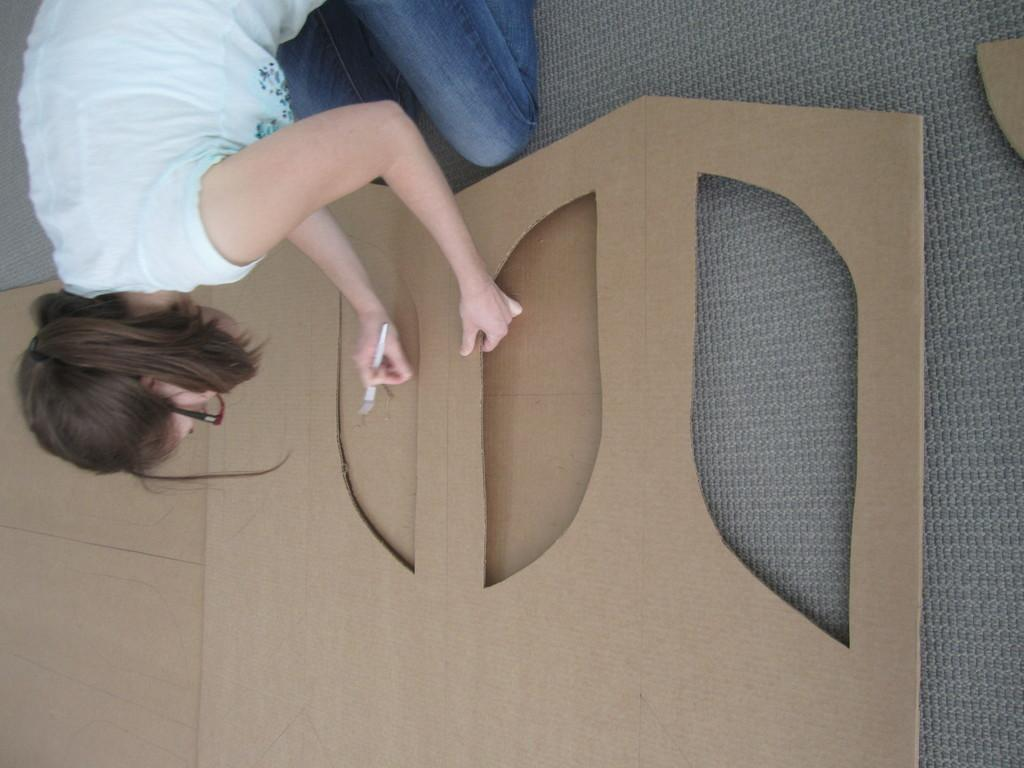Who is present in the image? There is a woman in the image. What is the woman holding in the image? The woman is holding an object, which is a cardboard. Can you describe the object the woman is holding? The woman is holding a cardboard with her hands. What type of cracker is the woman eating in the image? There is no cracker present in the image, and the woman is not eating anything. What disease is the woman suffering from in the image? There is no indication of any disease in the image, and we cannot make assumptions about the woman's health. 